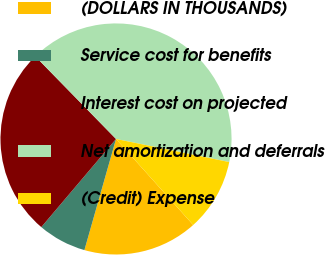Convert chart. <chart><loc_0><loc_0><loc_500><loc_500><pie_chart><fcel>(DOLLARS IN THOUSANDS)<fcel>Service cost for benefits<fcel>Interest cost on projected<fcel>Net amortization and deferrals<fcel>(Credit) Expense<nl><fcel>16.05%<fcel>6.78%<fcel>26.49%<fcel>40.52%<fcel>10.16%<nl></chart> 